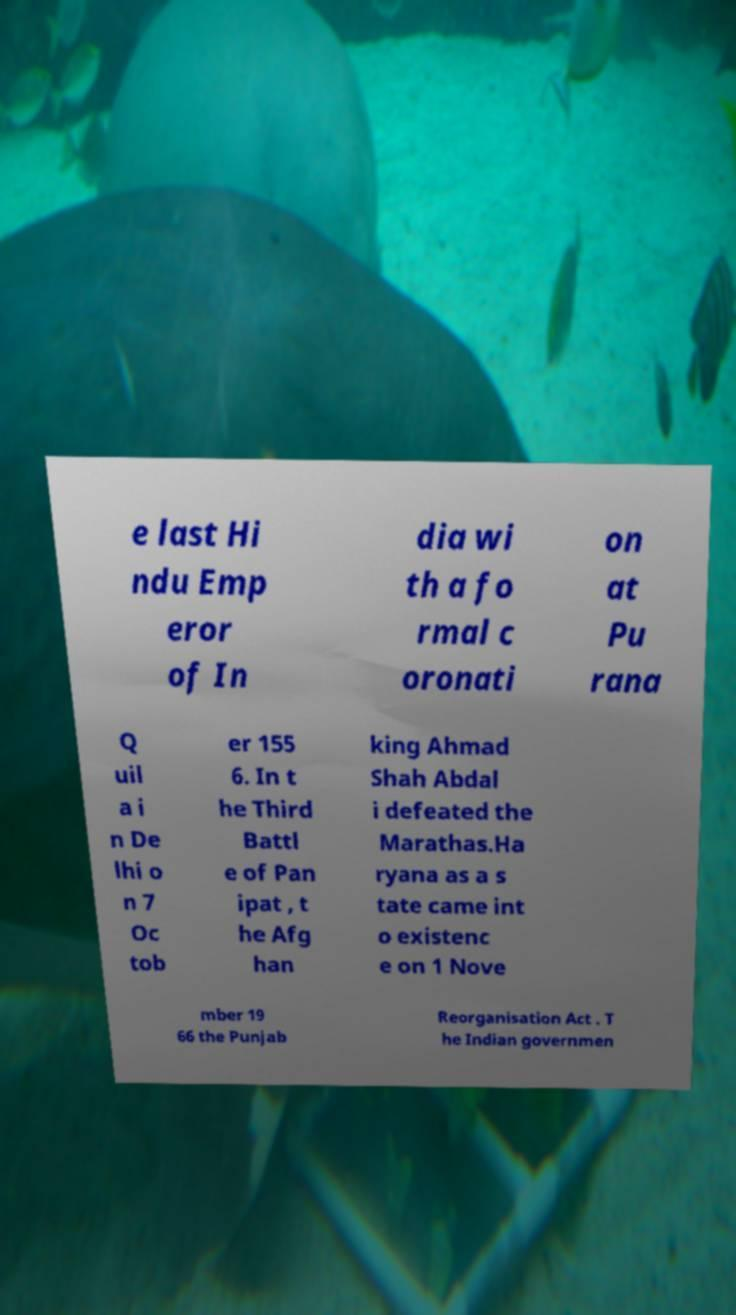What messages or text are displayed in this image? I need them in a readable, typed format. e last Hi ndu Emp eror of In dia wi th a fo rmal c oronati on at Pu rana Q uil a i n De lhi o n 7 Oc tob er 155 6. In t he Third Battl e of Pan ipat , t he Afg han king Ahmad Shah Abdal i defeated the Marathas.Ha ryana as a s tate came int o existenc e on 1 Nove mber 19 66 the Punjab Reorganisation Act . T he Indian governmen 